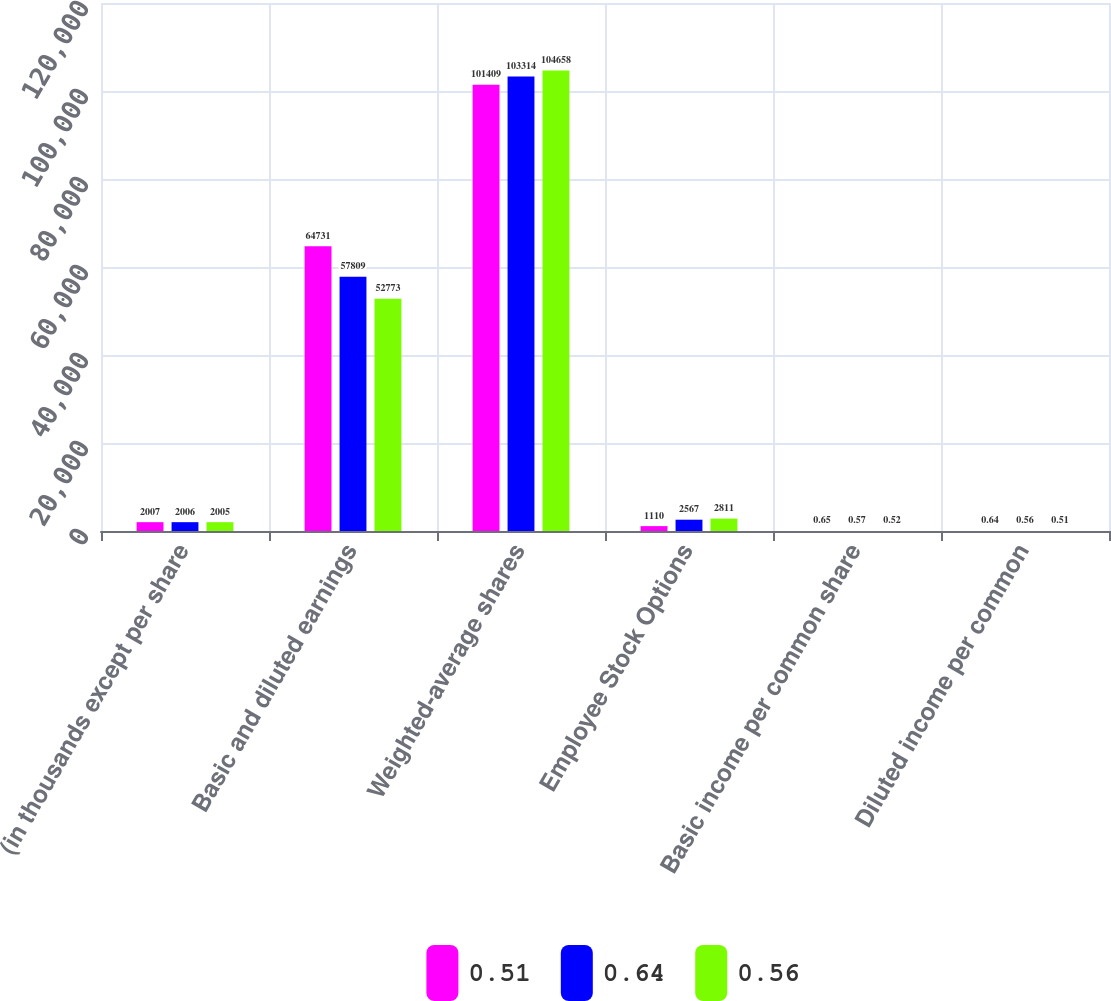<chart> <loc_0><loc_0><loc_500><loc_500><stacked_bar_chart><ecel><fcel>(in thousands except per share<fcel>Basic and diluted earnings<fcel>Weighted-average shares<fcel>Employee Stock Options<fcel>Basic income per common share<fcel>Diluted income per common<nl><fcel>0.51<fcel>2007<fcel>64731<fcel>101409<fcel>1110<fcel>0.65<fcel>0.64<nl><fcel>0.64<fcel>2006<fcel>57809<fcel>103314<fcel>2567<fcel>0.57<fcel>0.56<nl><fcel>0.56<fcel>2005<fcel>52773<fcel>104658<fcel>2811<fcel>0.52<fcel>0.51<nl></chart> 